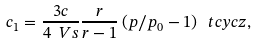<formula> <loc_0><loc_0><loc_500><loc_500>c _ { 1 } = \frac { 3 c } { 4 \ V s } \frac { r } { r - 1 } \left ( p / p _ { 0 } - 1 \right ) \ t c y c z ,</formula> 